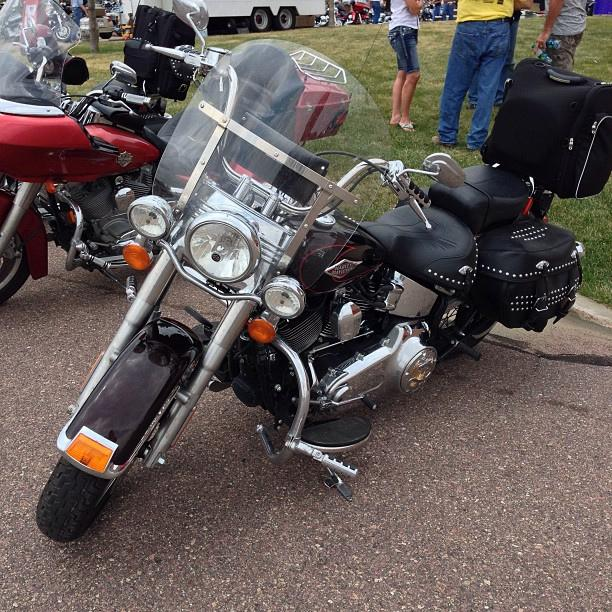Why is the man holding plastic bottles?

Choices:
A) to throw
B) to drink
C) to juggle
D) to sell to drink 